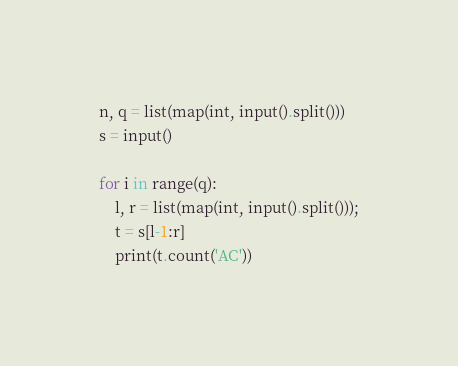Convert code to text. <code><loc_0><loc_0><loc_500><loc_500><_Python_>n, q = list(map(int, input().split()))
s = input()

for i in range(q):
    l, r = list(map(int, input().split()));
    t = s[l-1:r]
    print(t.count('AC'))</code> 